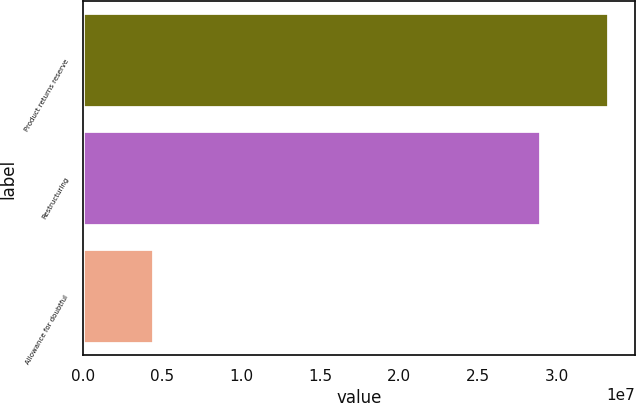Convert chart to OTSL. <chart><loc_0><loc_0><loc_500><loc_500><bar_chart><fcel>Product returns reserve<fcel>Restructuring<fcel>Allowance for doubtful<nl><fcel>3.3264e+07<fcel>2.894e+07<fcel>4.519e+06<nl></chart> 